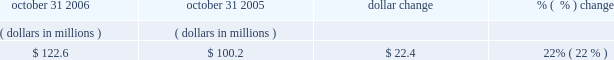Accounts receivable , net october 31 , 2006 october 31 , 2005 dollar change change .
The increase in accounts receivable was primarily due to the increased billings during the fiscal year ended october 31 , 2006 .
Days sales outstanding ( dso ) was 39 days at october 31 , 2006 and 36 days at october 31 , 2005 .
Our accounts receivable and dso are primarily driven by our billing and collections activities .
Net working capital working capital is comprised of current assets less current liabilities , as shown on our balance sheet .
As of october 31 , 2006 , our working capital was $ 23.4 million , compared to $ 130.6 million as of october 31 , 2005 .
The decrease in net working capital of $ 107.2 million was primarily due to ( 1 ) a decrease of $ 73.7 million in cash and cash equivalents ; ( 2 ) a decrease of current deferred tax assets of $ 83.2 million , primarily due to a tax accounting method change ; ( 3 ) a decrease in income taxes receivable of $ 5.8 million ; ( 4 ) an increase in income taxes payable of $ 21.5 million ; ( 5 ) an increase in deferred revenue of $ 29.9 million ; and ( 6 ) a net increase of $ 2.8 million in accounts payable and other liabilities which included a reclassification of debt of $ 7.5 million from long term to short term debt .
This decrease was partially offset by ( 1 ) an increase in short-term investments of $ 59.9 million ; ( 2 ) an increase in prepaid and other assets of $ 27.4 million , which includes land of $ 23.4 million reclassified from property plant and equipment to asset held for sale within prepaid expense and other assets on our consolidated balance sheet ; and ( 3 ) an increase in accounts receivable of $ 22.4 million .
Other commitments 2014revolving credit facility on october 20 , 2006 , we entered into a five-year , $ 300.0 million senior unsecured revolving credit facility providing for loans to synopsys and certain of its foreign subsidiaries .
The facility replaces our previous $ 250.0 million senior unsecured credit facility , which was terminated effective october 20 , 2006 .
The amount of the facility may be increased by up to an additional $ 150.0 million through the fourth year of the facility .
The facility contains financial covenants requiring us to maintain a minimum leverage ratio and specified levels of cash , as well as other non-financial covenants .
The facility terminates on october 20 , 2011 .
Borrowings under the facility bear interest at the greater of the administrative agent 2019s prime rate or the federal funds rate plus 0.50% ( 0.50 % ) ; however , we have the option to pay interest based on the outstanding amount at eurodollar rates plus a spread between 0.50% ( 0.50 % ) and 0.70% ( 0.70 % ) based on a pricing grid tied to a financial covenant .
In addition , commitment fees are payable on the facility at rates between 0.125% ( 0.125 % ) and 0.175% ( 0.175 % ) per year based on a pricing grid tied to a financial covenant .
As of october 31 , 2006 we had no outstanding borrowings under this credit facility and were in compliance with all the covenants .
We believe that our current cash , cash equivalents , short-term investments , cash generated from operations , and available credit under our credit facility will satisfy our business requirements for at least the next twelve months. .
What was the change in dso between 2005 and 2006? 
Rationale: faster collections lead to an increase in cashflow and decreased borrowing costs generally .
Computations: (39 - 36)
Answer: 3.0. 